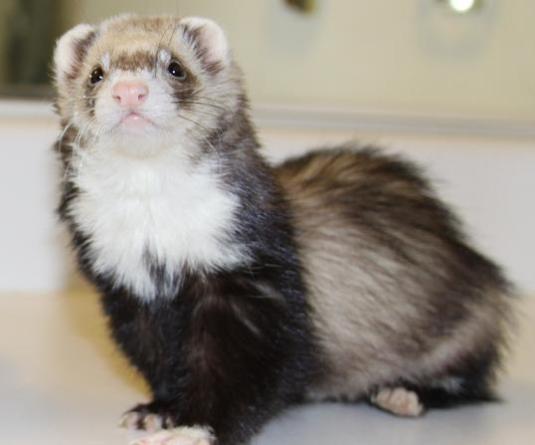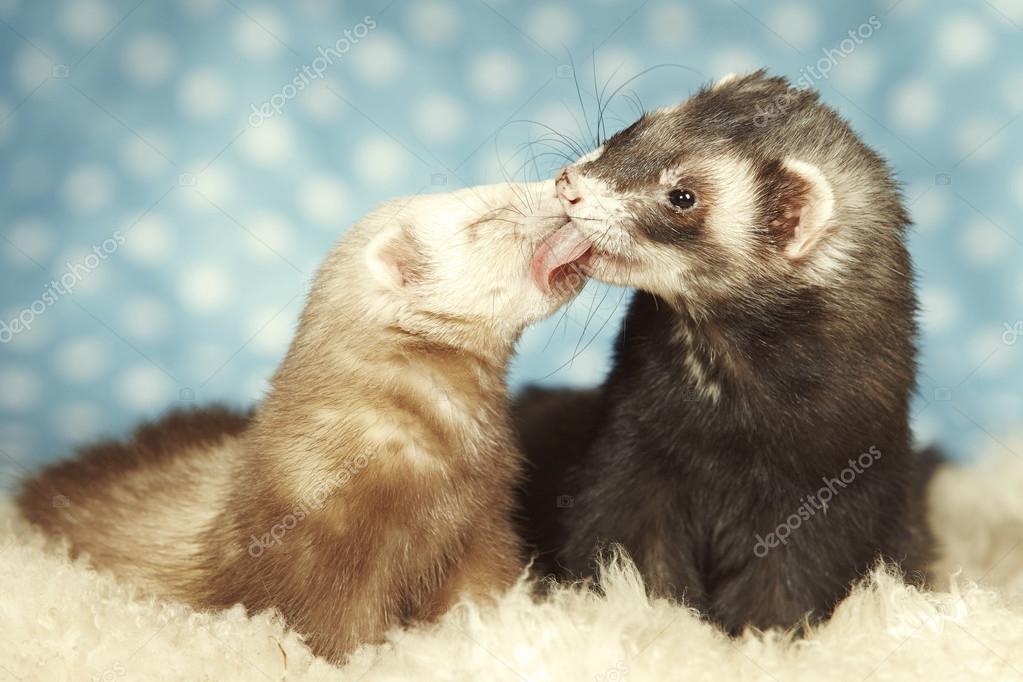The first image is the image on the left, the second image is the image on the right. Given the left and right images, does the statement "There are more animals in the image on the right." hold true? Answer yes or no. Yes. The first image is the image on the left, the second image is the image on the right. For the images shown, is this caption "The right image contains exactly two ferrets." true? Answer yes or no. Yes. 